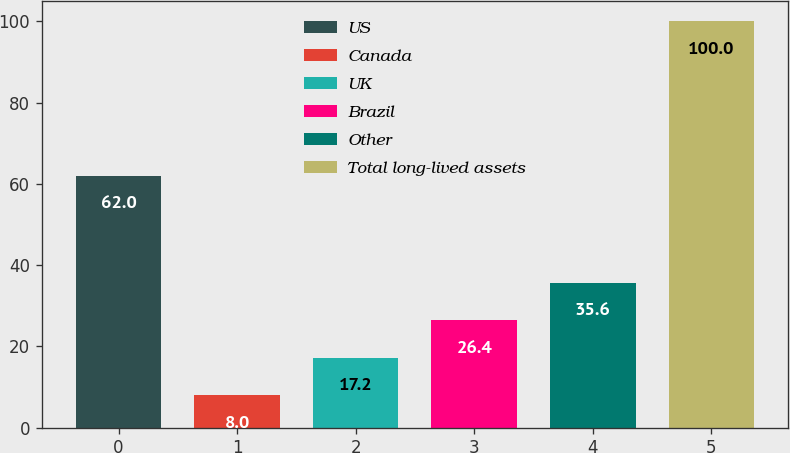<chart> <loc_0><loc_0><loc_500><loc_500><bar_chart><fcel>US<fcel>Canada<fcel>UK<fcel>Brazil<fcel>Other<fcel>Total long-lived assets<nl><fcel>62<fcel>8<fcel>17.2<fcel>26.4<fcel>35.6<fcel>100<nl></chart> 